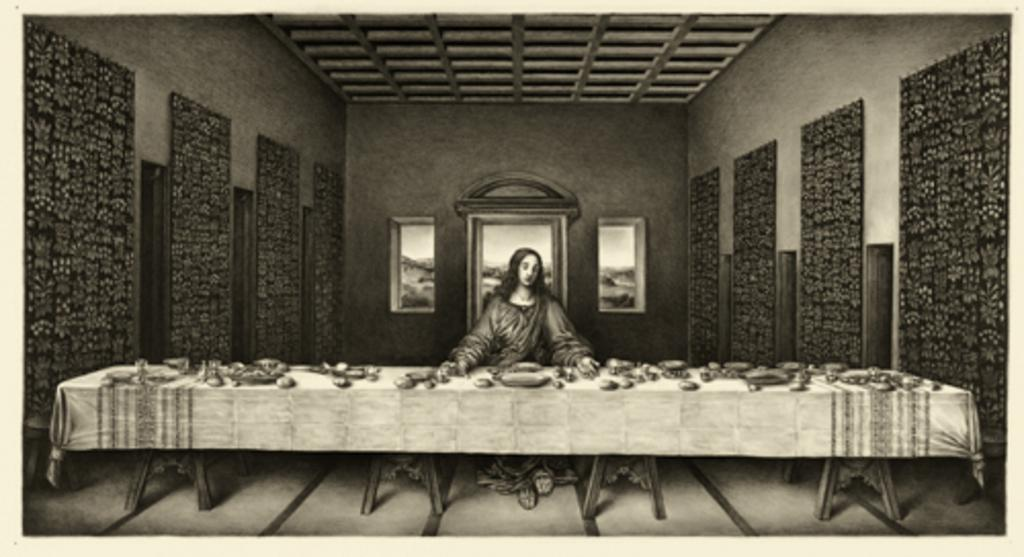What is the main subject of the image? There is a photo of a woman in the image. What can be seen in the background of the image? The ceiling and wall are visible in the image. What is the color scheme of the image? The image is black and white in color. What is located in the foreground of the image? There is a table in the image. What is on the table in the image? There are objects on the table. What type of sand can be seen in the image? There is no sand present in the image; it features a photo of a woman, a table, and objects on the table. What religious symbols are visible in the image? There are no religious symbols visible in the image. 